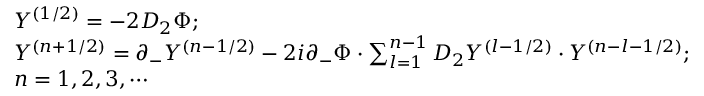Convert formula to latex. <formula><loc_0><loc_0><loc_500><loc_500>\begin{array} { l } { { Y ^ { ( 1 / 2 ) } = - 2 D _ { 2 } \Phi ; } } \\ { { Y ^ { ( n + 1 / 2 ) } = \partial _ { - } Y ^ { ( n - 1 / 2 ) } - 2 i \partial _ { - } \Phi \cdot \sum _ { l = 1 } ^ { n - 1 } D _ { 2 } Y ^ { ( l - 1 / 2 ) } \cdot Y ^ { ( n - l - 1 / 2 ) } ; } } \\ { n = 1 , 2 , 3 , \cdots } \end{array}</formula> 